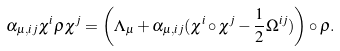<formula> <loc_0><loc_0><loc_500><loc_500>\alpha _ { \mu , i j } \chi ^ { i } \rho \chi ^ { j } = \left ( \Lambda _ { \mu } + \alpha _ { \mu , i j } ( \chi ^ { i } \circ \chi ^ { j } - \frac { 1 } { 2 } \Omega ^ { i j } ) \right ) \circ \rho .</formula> 